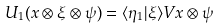Convert formula to latex. <formula><loc_0><loc_0><loc_500><loc_500>U _ { 1 } ( x \otimes \xi \otimes \psi ) = \langle \eta _ { 1 } | \xi \rangle V x \otimes \psi</formula> 